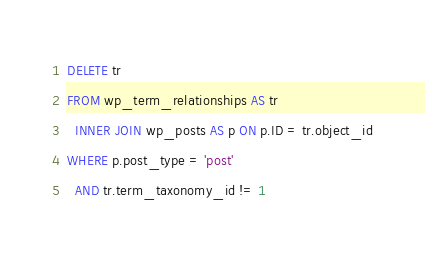<code> <loc_0><loc_0><loc_500><loc_500><_SQL_>DELETE tr
FROM wp_term_relationships AS tr
  INNER JOIN wp_posts AS p ON p.ID = tr.object_id
WHERE p.post_type = 'post'
  AND tr.term_taxonomy_id != 1
</code> 